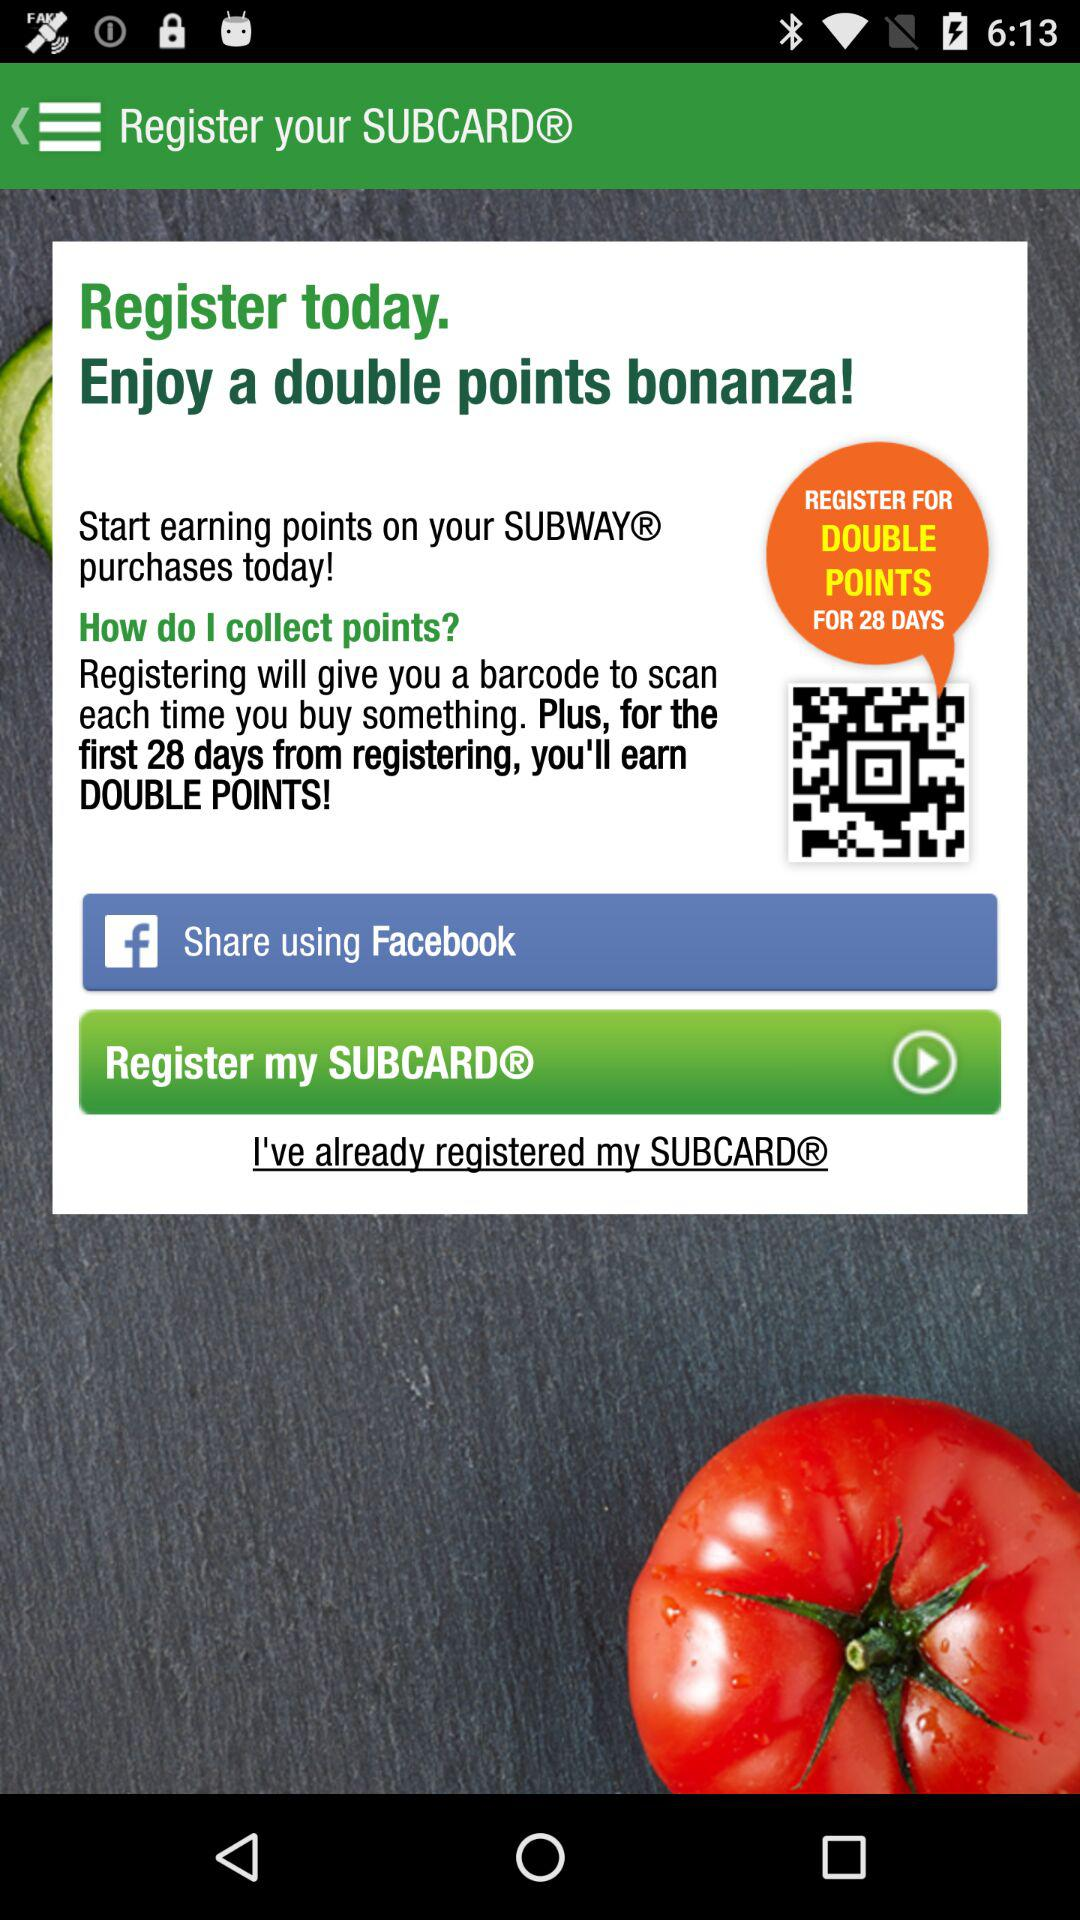What account can be used to share? The account that can be used to share is "Facebook". 